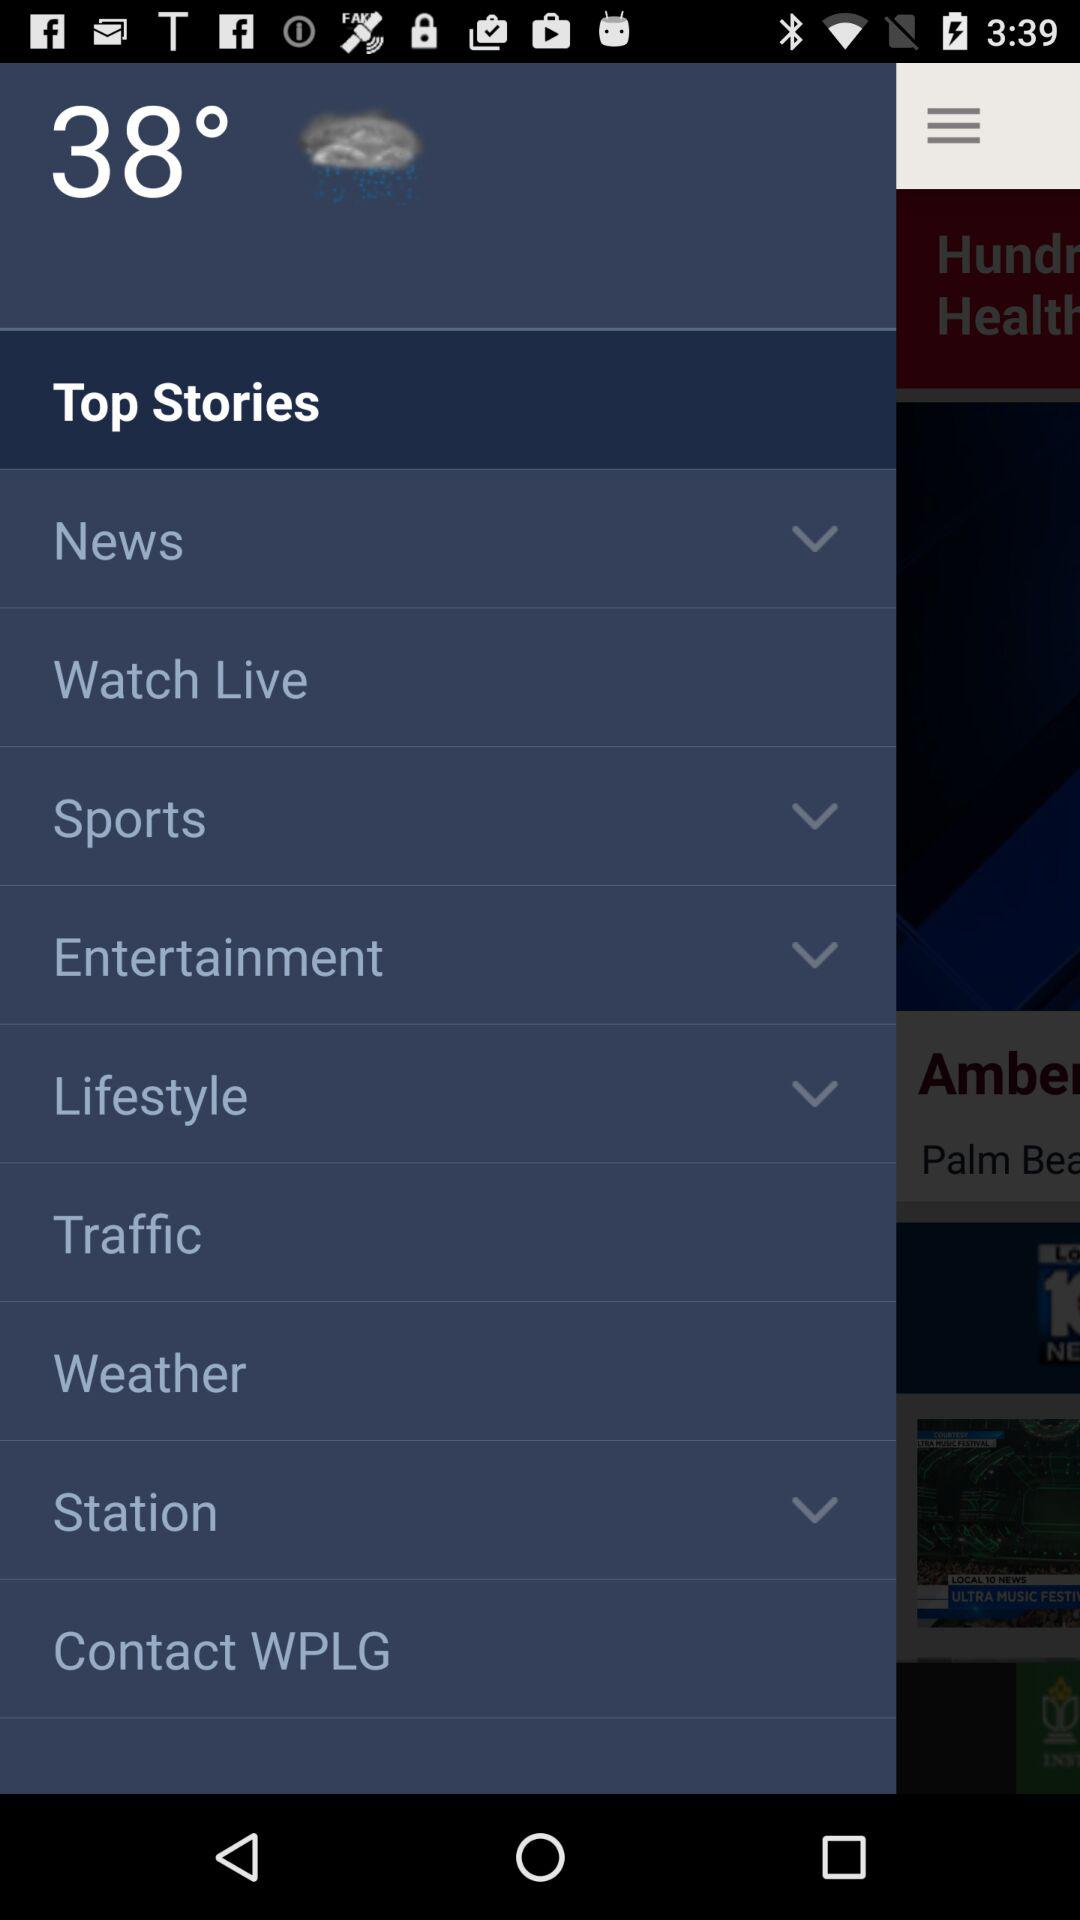What is the given temperature? The given temperature is 38°. 